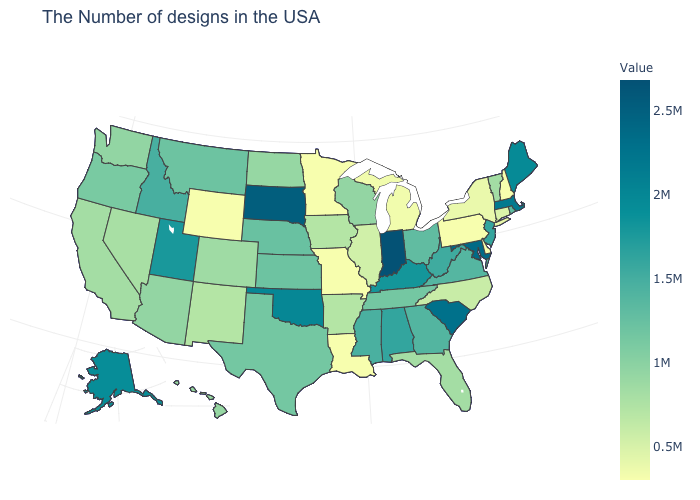Among the states that border Michigan , which have the highest value?
Answer briefly. Indiana. Among the states that border Michigan , which have the highest value?
Answer briefly. Indiana. Does Washington have a lower value than Michigan?
Keep it brief. No. Does Maine have a lower value than South Carolina?
Give a very brief answer. Yes. Among the states that border Colorado , does Utah have the highest value?
Short answer required. No. 